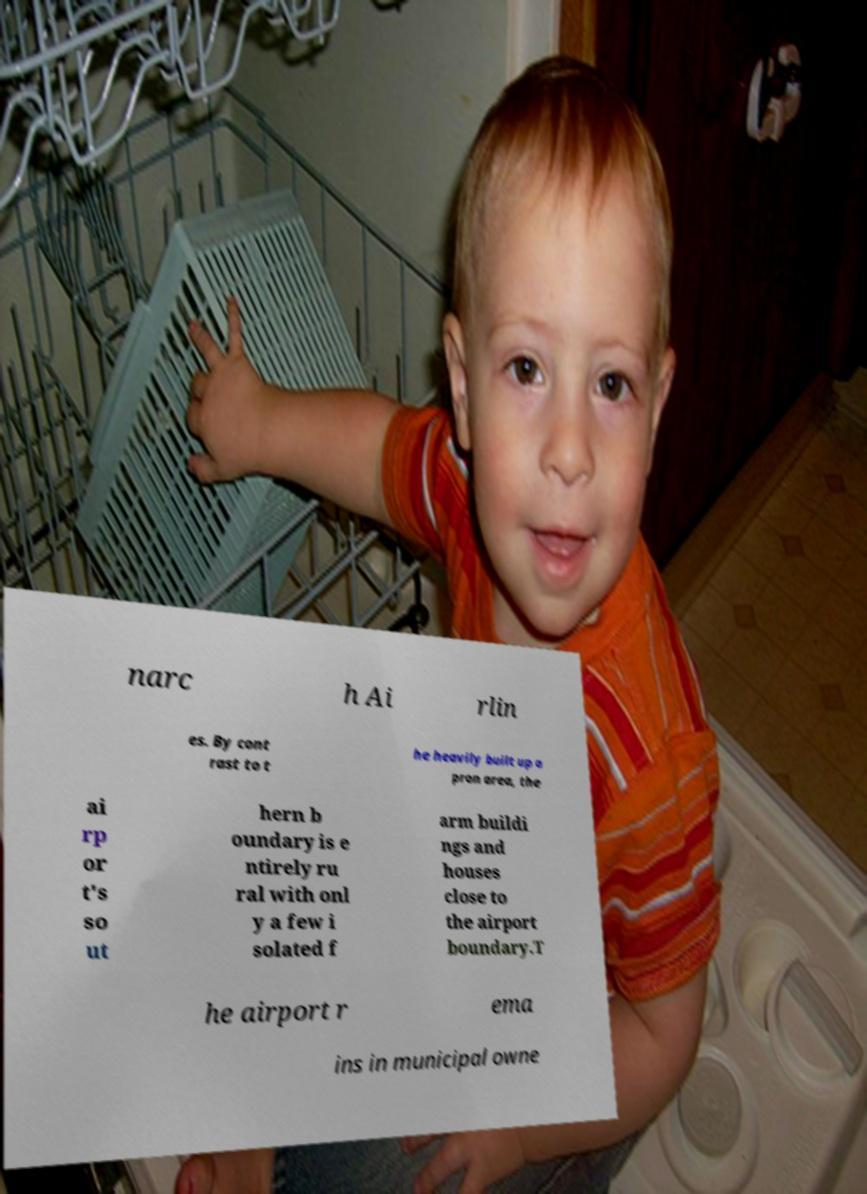Could you extract and type out the text from this image? narc h Ai rlin es. By cont rast to t he heavily built up a pron area, the ai rp or t's so ut hern b oundary is e ntirely ru ral with onl y a few i solated f arm buildi ngs and houses close to the airport boundary.T he airport r ema ins in municipal owne 